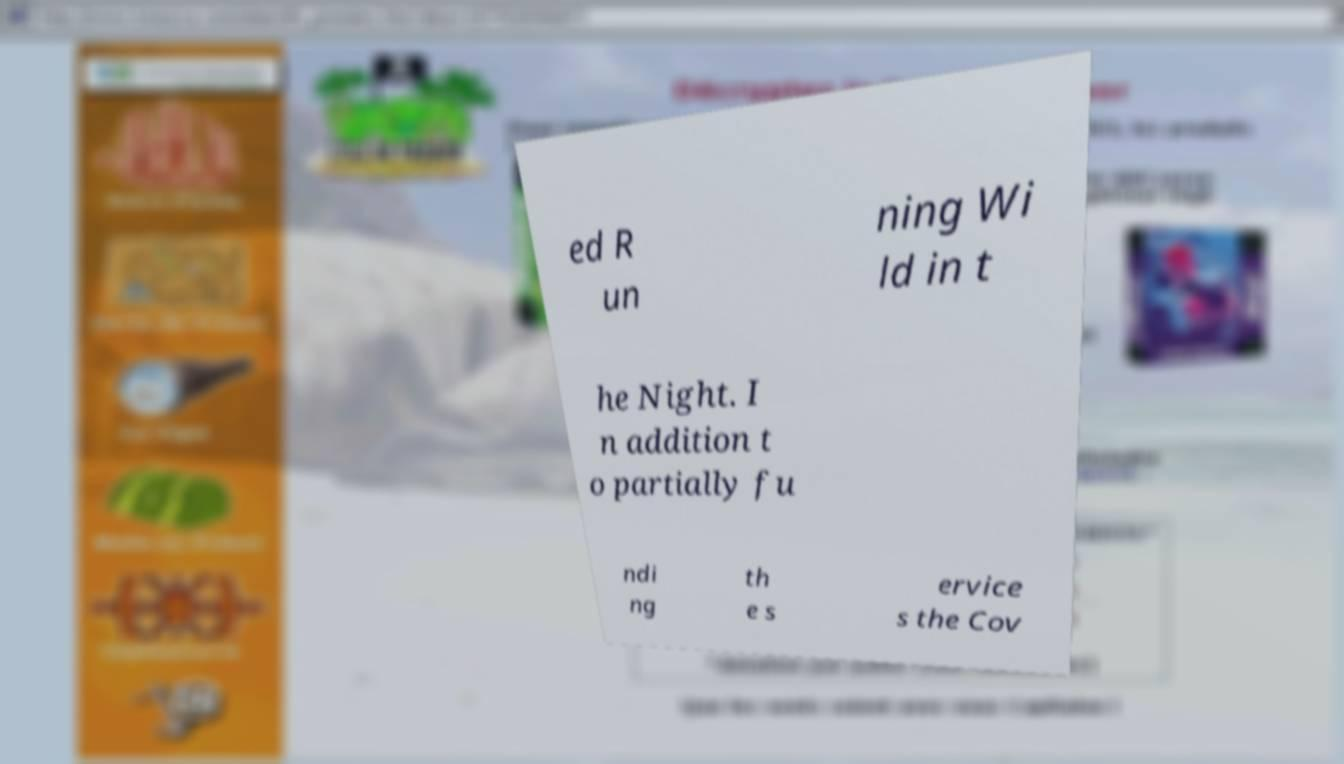Can you read and provide the text displayed in the image?This photo seems to have some interesting text. Can you extract and type it out for me? ed R un ning Wi ld in t he Night. I n addition t o partially fu ndi ng th e s ervice s the Cov 